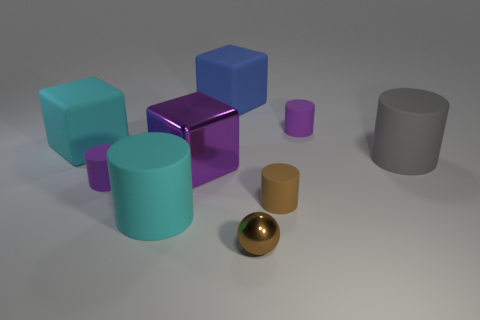There is a object that is both in front of the brown matte object and left of the big purple thing; what is its shape?
Your answer should be compact. Cylinder. What number of objects have the same material as the large cyan cube?
Your response must be concise. 6. What number of cyan cubes are in front of the purple rubber cylinder behind the gray object?
Offer a terse response. 1. What is the shape of the large thing behind the tiny purple cylinder that is right of the big object that is behind the large cyan matte cube?
Your response must be concise. Cube. What size is the thing that is the same color as the metal sphere?
Your answer should be very brief. Small. How many things are either brown matte things or big matte balls?
Offer a very short reply. 1. What color is the metal thing that is the same size as the brown matte cylinder?
Make the answer very short. Brown. There is a large gray object; does it have the same shape as the small purple thing that is on the right side of the blue block?
Offer a terse response. Yes. How many objects are purple things on the right side of the brown metal thing or cylinders on the left side of the blue object?
Give a very brief answer. 3. What shape is the other thing that is the same color as the tiny metal thing?
Offer a terse response. Cylinder. 